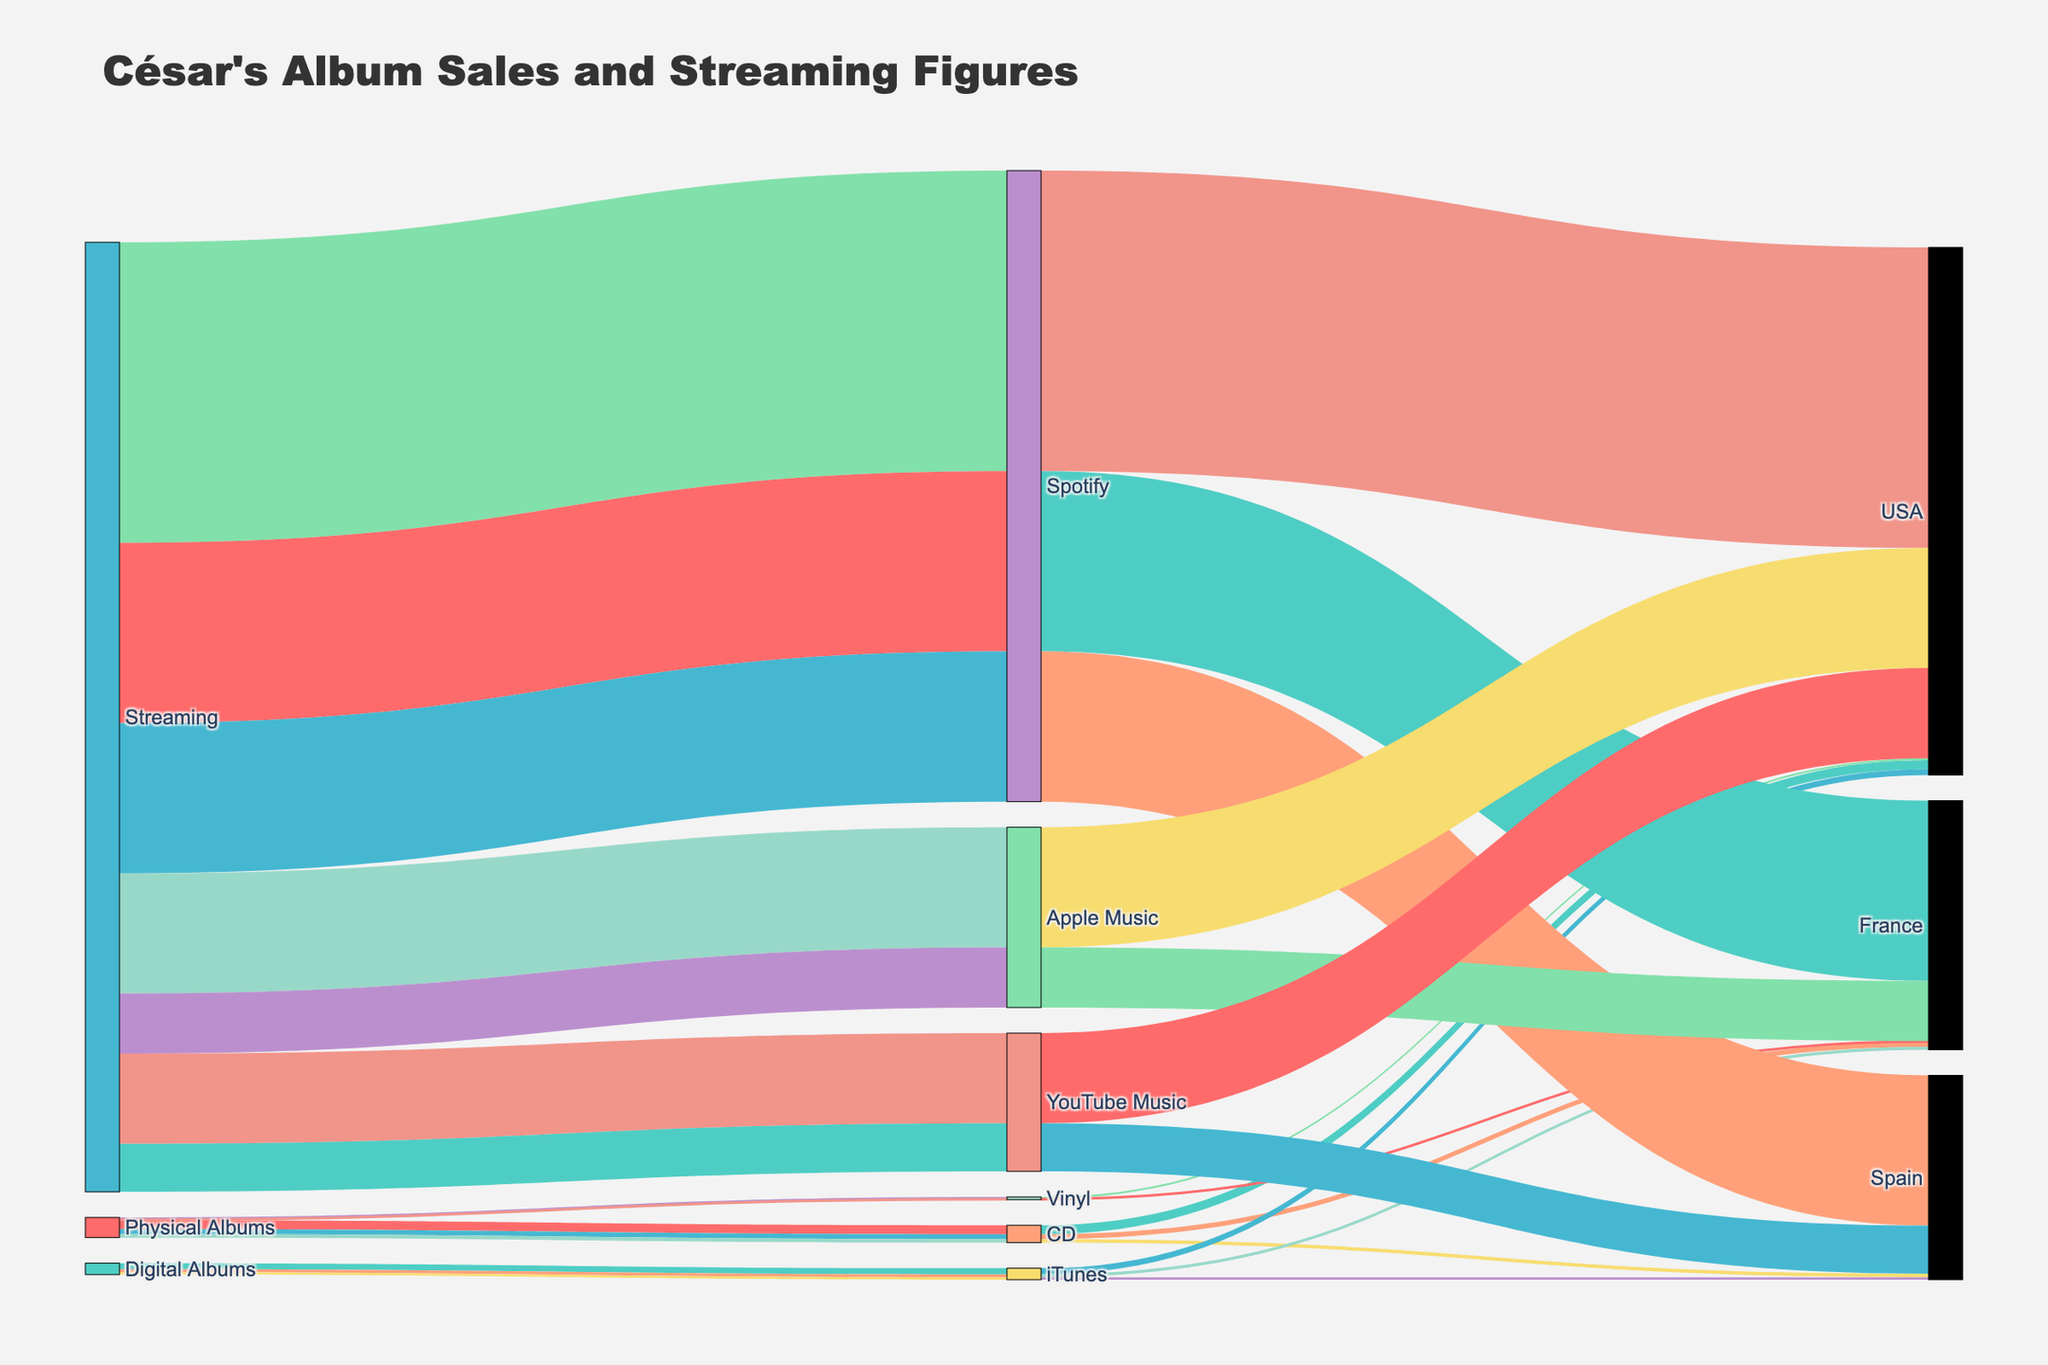What is the title of the Sankey Diagram? The Sankey Diagram's title is usually displayed prominently at the top of the figure. The title provides a summary of what information the figure conveys, which helps users quickly understand the context of the data. Here, the title of the Sankey Diagram indicates it represents the album sales and streaming figures of César, broken down by market share across different countries and platforms.
Answer: César's Album Sales and Streaming Figures What are the unique sources listed in the figure? By looking at the connections from the leftmost nodes in the diagram, we can identify the unique sources. Each source is represented by a distinct node, labeled appropriately. In this scenario, the sources are likely to be the different forms of how music can be produced or distributed.
Answer: Physical Albums, Digital Albums, Streaming Which platform has the most data flows connected to different countries? This can be determined by visually inspecting the diagram and counting the number of connections (or flows) originating from each platform node to various country nodes. The platform with the highest number of unique flows spans the greatest number of countries.
Answer: Spotify Which country has the highest overall figures combined from all platforms? To answer this, sum up the figures (sales/streams) from all platforms for each country node. Visually, the thickness of the flows leading to a country can also be indicative of the combined figures. By comparing these, you can identify the country with the highest overall figures.
Answer: USA Among the digital albums, which country shows the highest sales? Focus on the flows originating from 'Digital Albums' node and concentrate on those directed towards various countries, while disregarding platform sub-nodes. By comparing the thickness or numerical values attached to these flows, you can determine the country with the highest sales for digital albums.
Answer: USA Which streaming service accounts for the largest share in Spain? Observe the connections from the 'Streaming' node towards the Spain node, taking into account the different services. Compare these flows visually or numerically to identify the largest share.
Answer: Spotify What is the combined total of album sales from physical albums in the USA and France? To find this, sum the figures of physical CD and vinyl sales in the USA and France entries. This involves adding up numbers from these respective categories.
Answer: 195000 (USA: 150000 + 30000, France: 80000 + 15000) Which platform reported the lowest total figures across all countries? Sum the figures for each platform across all countries and then compare these totals to identify the platform with the lowest combined figures.
Answer: YouTube Music Between vinyl and digital sales in France, which has the higher value? Compare the summed figures from all vinyl sales in France with the summed figures from all digital sales in France by looking at the respective flows from 'Physical Albums' and 'Digital Albums' towards France. Determine which is higher based on these sums.
Answer: Digital Sales If we combine the figures from all streaming platforms, which platform represents the highest share in overall figures? Aggregate the figures for all streaming platforms and then compare these sums to determine which platform has the highest overall figures. This requires summing individual figures and performing a comparison.
Answer: Spotify 